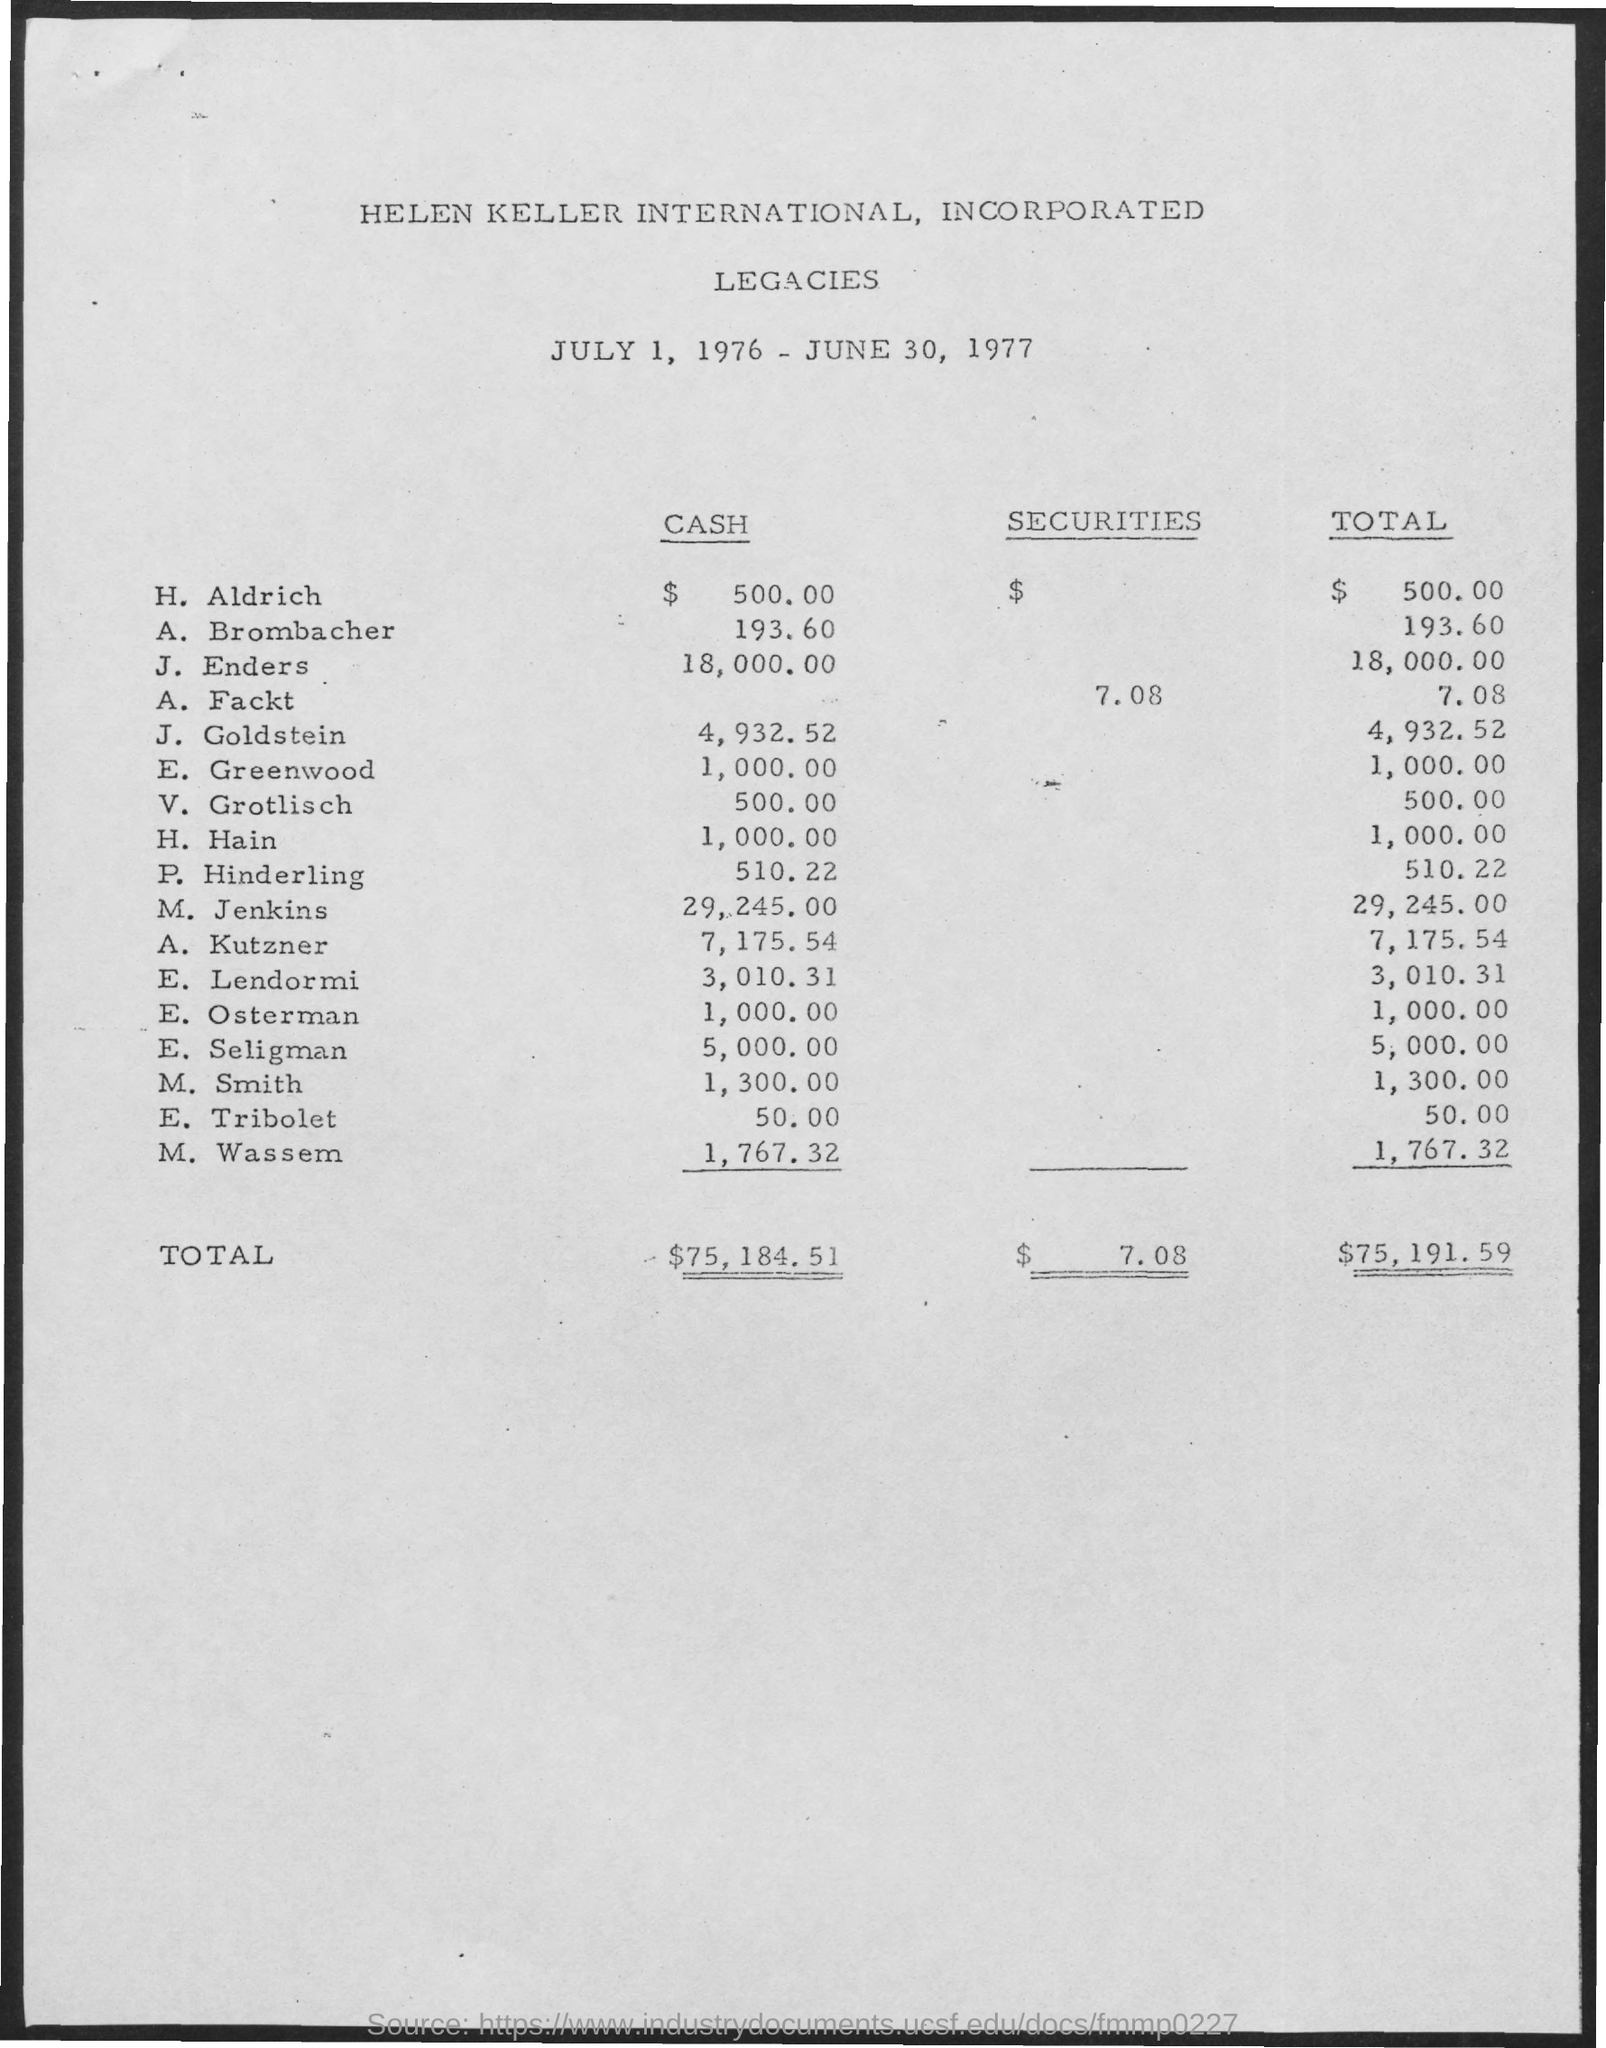Mention a couple of crucial points in this snapshot. The total for A. Fackt is 7.08. What is the total for H. Hain? It is 1,000.00. The total for J. Goldstein is 4,932.52. The total for J. Enders is 18,000.00. The total for H. Aldrich is $500.00. 